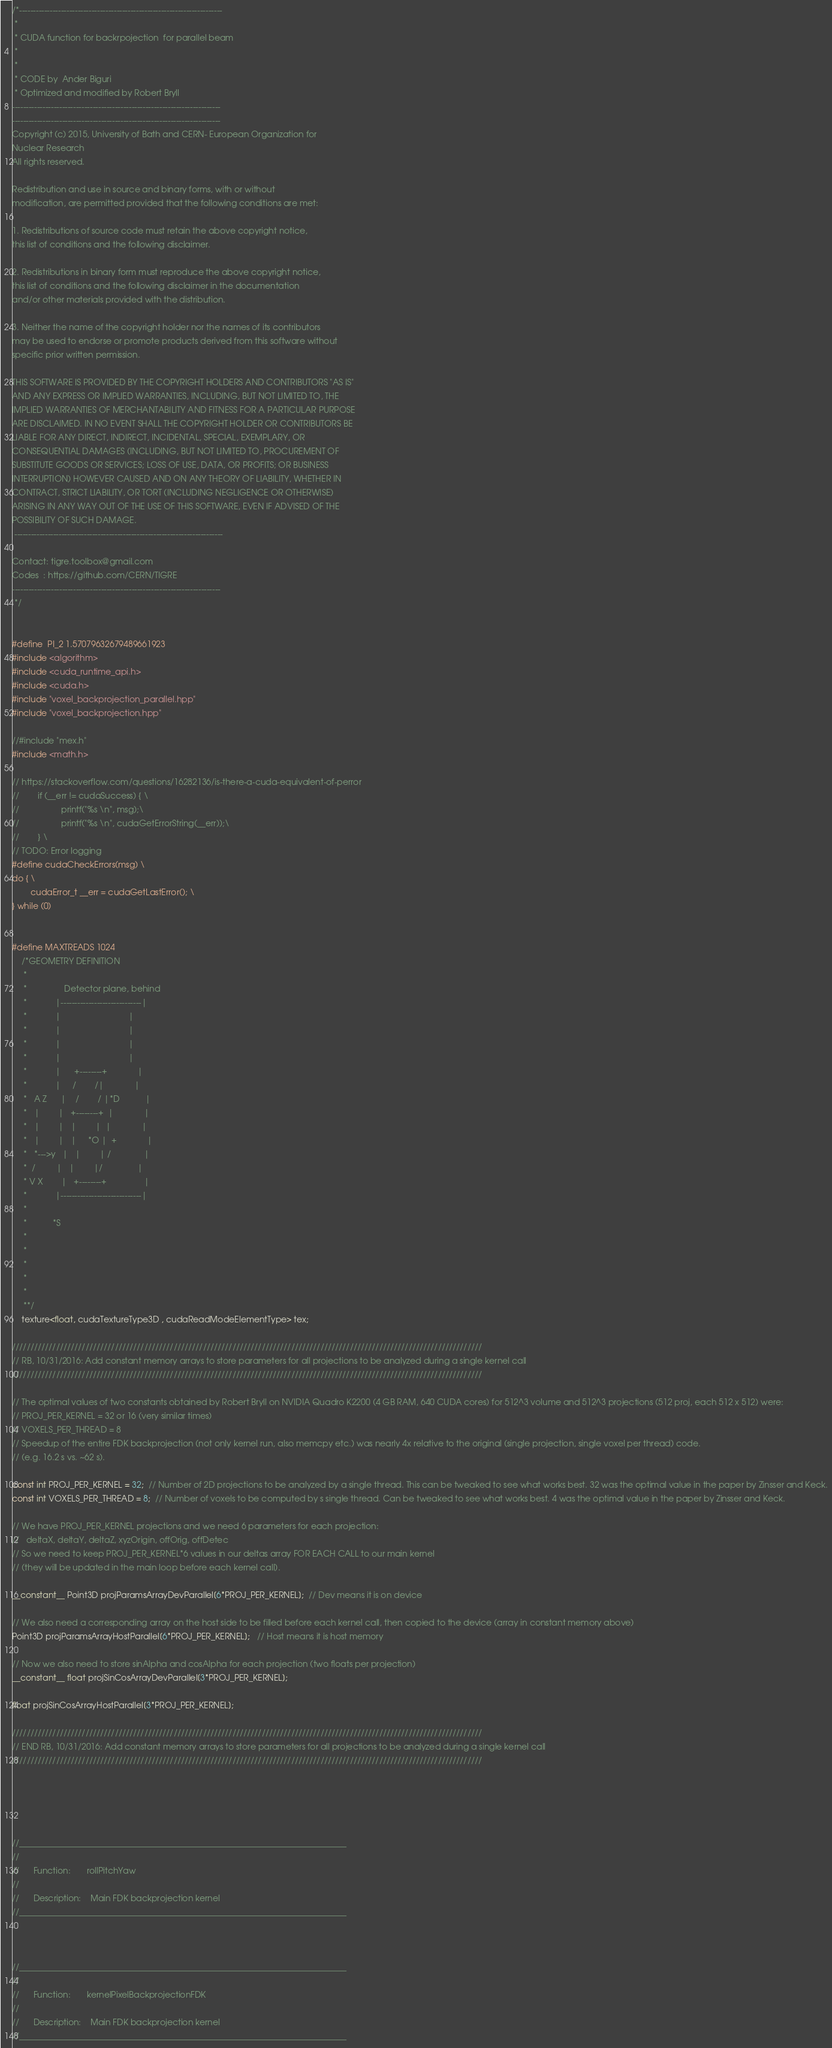<code> <loc_0><loc_0><loc_500><loc_500><_Cuda_>/*-------------------------------------------------------------------------
 *
 * CUDA function for backrpojection  for parallel beam
 *
 *
 * CODE by  Ander Biguri
 * Optimized and modified by Robert Bryll
---------------------------------------------------------------------------
---------------------------------------------------------------------------
Copyright (c) 2015, University of Bath and CERN- European Organization for 
Nuclear Research
All rights reserved.

Redistribution and use in source and binary forms, with or without 
modification, are permitted provided that the following conditions are met:

1. Redistributions of source code must retain the above copyright notice, 
this list of conditions and the following disclaimer.

2. Redistributions in binary form must reproduce the above copyright notice, 
this list of conditions and the following disclaimer in the documentation 
and/or other materials provided with the distribution.

3. Neither the name of the copyright holder nor the names of its contributors
may be used to endorse or promote products derived from this software without
specific prior written permission.

THIS SOFTWARE IS PROVIDED BY THE COPYRIGHT HOLDERS AND CONTRIBUTORS "AS IS" 
AND ANY EXPRESS OR IMPLIED WARRANTIES, INCLUDING, BUT NOT LIMITED TO, THE 
IMPLIED WARRANTIES OF MERCHANTABILITY AND FITNESS FOR A PARTICULAR PURPOSE 
ARE DISCLAIMED. IN NO EVENT SHALL THE COPYRIGHT HOLDER OR CONTRIBUTORS BE 
LIABLE FOR ANY DIRECT, INDIRECT, INCIDENTAL, SPECIAL, EXEMPLARY, OR 
CONSEQUENTIAL DAMAGES (INCLUDING, BUT NOT LIMITED TO, PROCUREMENT OF 
SUBSTITUTE GOODS OR SERVICES; LOSS OF USE, DATA, OR PROFITS; OR BUSINESS 
INTERRUPTION) HOWEVER CAUSED AND ON ANY THEORY OF LIABILITY, WHETHER IN 
CONTRACT, STRICT LIABILITY, OR TORT (INCLUDING NEGLIGENCE OR OTHERWISE)
ARISING IN ANY WAY OUT OF THE USE OF THIS SOFTWARE, EVEN IF ADVISED OF THE
POSSIBILITY OF SUCH DAMAGE.
 ---------------------------------------------------------------------------

Contact: tigre.toolbox@gmail.com
Codes  : https://github.com/CERN/TIGRE
--------------------------------------------------------------------------- 
 */

 
#define  PI_2 1.57079632679489661923
#include <algorithm>
#include <cuda_runtime_api.h>
#include <cuda.h>
#include "voxel_backprojection_parallel.hpp"
#include "voxel_backprojection.hpp"

//#include "mex.h"
#include <math.h>

// https://stackoverflow.com/questions/16282136/is-there-a-cuda-equivalent-of-perror
//        if (__err != cudaSuccess) { \
//                  printf("%s \n", msg);\
//                  printf("%s \n", cudaGetErrorString(__err));\
//        } \
// TODO: Error logging
#define cudaCheckErrors(msg) \
do { \
        cudaError_t __err = cudaGetLastError(); \
} while (0)
    
    
#define MAXTREADS 1024
    /*GEOMETRY DEFINITION
     *
     *                Detector plane, behind
     *            |-----------------------------|
     *            |                             |
     *            |                             |
     *            |                             |
     *            |                             |
     *            |      +--------+             |
     *            |     /        /|             |
     *   A Z      |    /        / |*D           |
     *   |        |   +--------+  |             |
     *   |        |   |        |  |             |
     *   |        |   |     *O |  +             |
     *   *--->y   |   |        | /              |
     *  /         |   |        |/               |
     * V X        |   +--------+                |
     *            |-----------------------------|
     *
     *           *S
     *
     *
     *
     *
     *
     **/
    texture<float, cudaTextureType3D , cudaReadModeElementType> tex;

////////////////////////////////////////////////////////////////////////////////////////////////////////////////////////////////
// RB, 10/31/2016: Add constant memory arrays to store parameters for all projections to be analyzed during a single kernel call
////////////////////////////////////////////////////////////////////////////////////////////////////////////////////////////////

// The optimal values of two constants obtained by Robert Bryll on NVIDIA Quadro K2200 (4 GB RAM, 640 CUDA cores) for 512^3 volume and 512^3 projections (512 proj, each 512 x 512) were:
// PROJ_PER_KERNEL = 32 or 16 (very similar times)
// VOXELS_PER_THREAD = 8
// Speedup of the entire FDK backprojection (not only kernel run, also memcpy etc.) was nearly 4x relative to the original (single projection, single voxel per thread) code.
// (e.g. 16.2 s vs. ~62 s).

const int PROJ_PER_KERNEL = 32;  // Number of 2D projections to be analyzed by a single thread. This can be tweaked to see what works best. 32 was the optimal value in the paper by Zinsser and Keck.
const int VOXELS_PER_THREAD = 8;  // Number of voxels to be computed by s single thread. Can be tweaked to see what works best. 4 was the optimal value in the paper by Zinsser and Keck.

// We have PROJ_PER_KERNEL projections and we need 6 parameters for each projection:
//   deltaX, deltaY, deltaZ, xyzOrigin, offOrig, offDetec
// So we need to keep PROJ_PER_KERNEL*6 values in our deltas array FOR EACH CALL to our main kernel
// (they will be updated in the main loop before each kernel call).

__constant__ Point3D projParamsArrayDevParallel[6*PROJ_PER_KERNEL];  // Dev means it is on device

// We also need a corresponding array on the host side to be filled before each kernel call, then copied to the device (array in constant memory above)
Point3D projParamsArrayHostParallel[6*PROJ_PER_KERNEL];   // Host means it is host memory

// Now we also need to store sinAlpha and cosAlpha for each projection (two floats per projection)
__constant__ float projSinCosArrayDevParallel[3*PROJ_PER_KERNEL];

float projSinCosArrayHostParallel[3*PROJ_PER_KERNEL];

////////////////////////////////////////////////////////////////////////////////////////////////////////////////////////////////
// END RB, 10/31/2016: Add constant memory arrays to store parameters for all projections to be analyzed during a single kernel call
////////////////////////////////////////////////////////////////////////////////////////////////////////////////////////////////





//______________________________________________________________________________
//
//      Function:       rollPitchYaw
//
//      Description:    Main FDK backprojection kernel
//______________________________________________________________________________



//______________________________________________________________________________
//
//      Function:       kernelPixelBackprojectionFDK
//
//      Description:    Main FDK backprojection kernel
//______________________________________________________________________________
</code> 